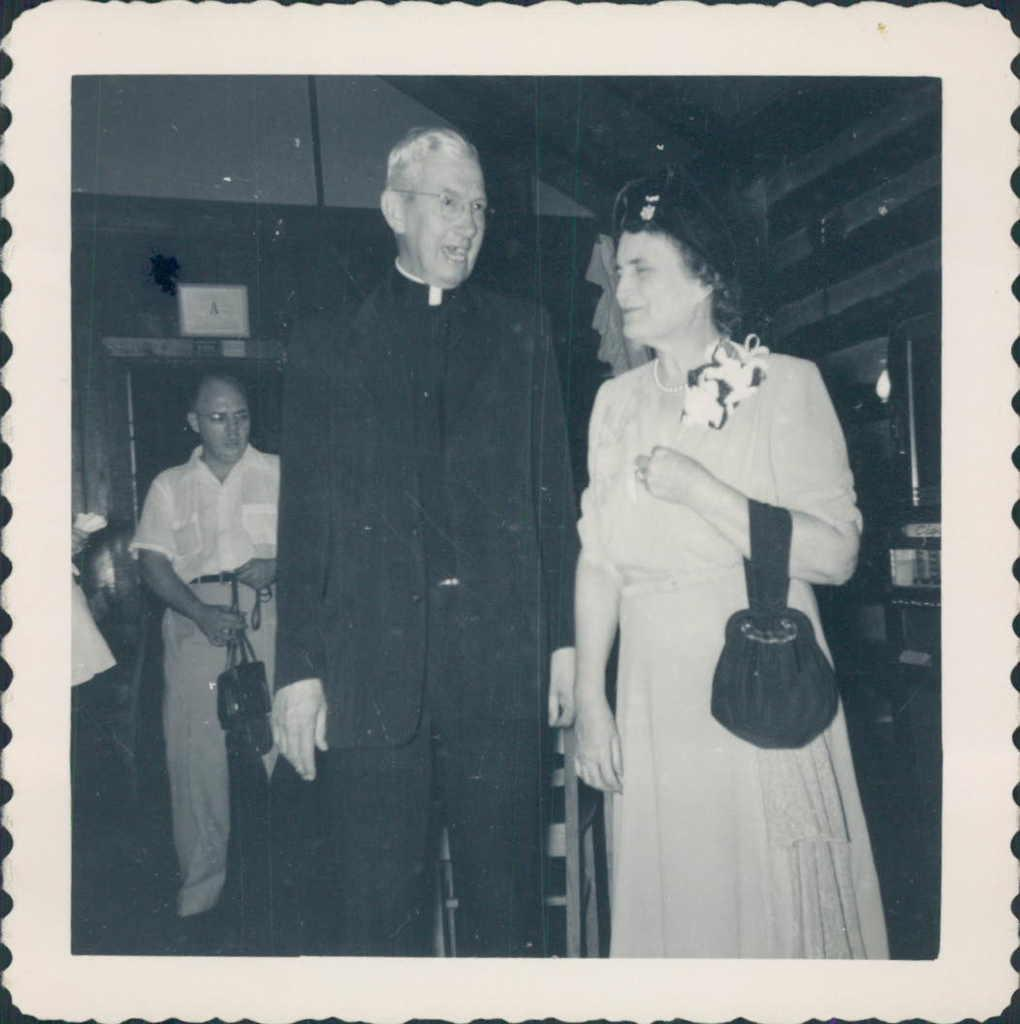How many people are in the image? There are three people in the image: a man, a woman, and a person standing on the left side. What are the man and woman doing in the image? The man and woman are in the middle of the image, but their actions are not specified. What is the color scheme of the image? The image is in black and white color. How many cats are visible in the image? There are no cats present in the image. What type of lipstick is the woman wearing in the image? The image is in black and white color, so it is not possible to determine the type of lipstick the woman might be wearing. 